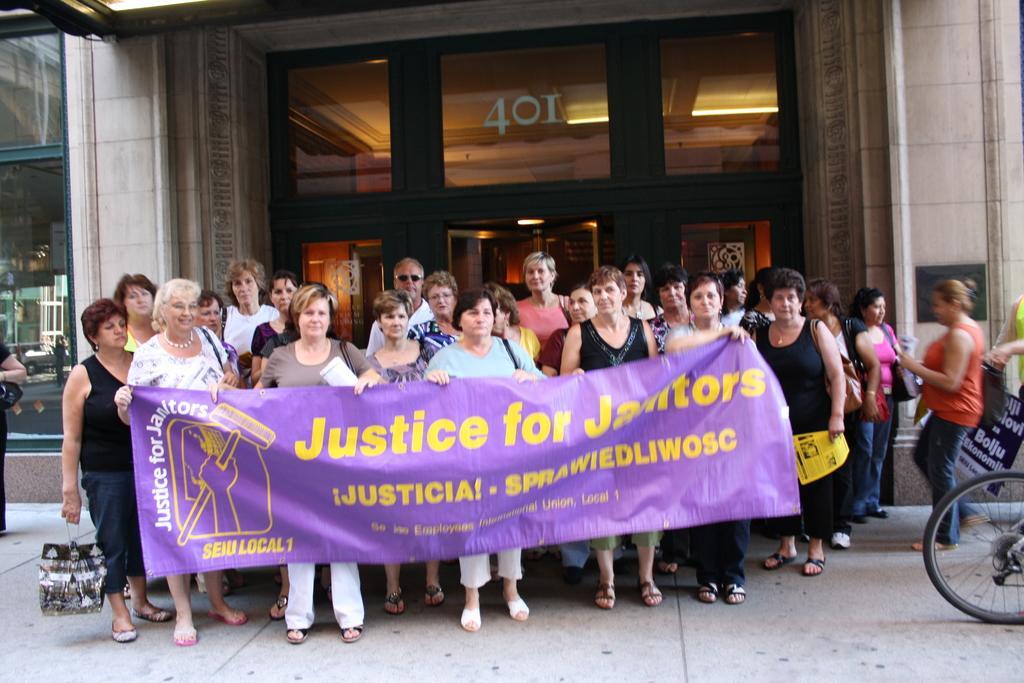Can you describe this image briefly? In this image there are group of persons standing, there are persons holding an objects, there are persons holding a banner, there is text on the banner, there is a person truncated towards the right of the image, there is a vehicle truncated towards the right of the image, there is a person truncated towards the left of the image, there is a glass window truncated towards the left of the image, there is a wall, there is door, there is a number on the glass surface, there are lights on the roof. 